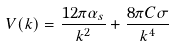<formula> <loc_0><loc_0><loc_500><loc_500>V ( k ) = \frac { 1 2 \pi \alpha _ { s } } { k ^ { 2 } } + \frac { 8 \pi C \sigma } { k ^ { 4 } }</formula> 